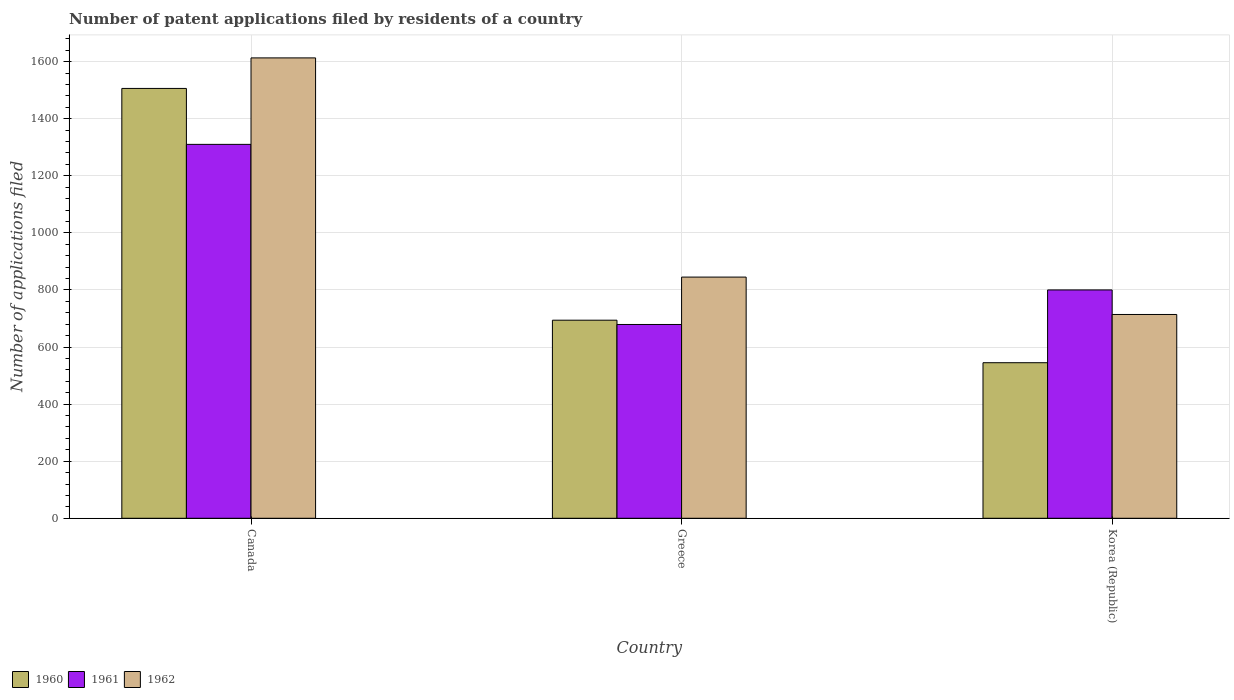How many bars are there on the 2nd tick from the right?
Make the answer very short. 3. In how many cases, is the number of bars for a given country not equal to the number of legend labels?
Ensure brevity in your answer.  0. What is the number of applications filed in 1961 in Greece?
Offer a very short reply. 679. Across all countries, what is the maximum number of applications filed in 1960?
Your answer should be compact. 1506. Across all countries, what is the minimum number of applications filed in 1960?
Your answer should be compact. 545. In which country was the number of applications filed in 1962 minimum?
Your response must be concise. Korea (Republic). What is the total number of applications filed in 1962 in the graph?
Make the answer very short. 3172. What is the difference between the number of applications filed in 1960 in Canada and that in Greece?
Offer a very short reply. 812. What is the difference between the number of applications filed in 1961 in Greece and the number of applications filed in 1962 in Korea (Republic)?
Your answer should be compact. -35. What is the average number of applications filed in 1962 per country?
Provide a succinct answer. 1057.33. What is the difference between the number of applications filed of/in 1962 and number of applications filed of/in 1960 in Greece?
Your answer should be very brief. 151. What is the ratio of the number of applications filed in 1962 in Canada to that in Korea (Republic)?
Provide a succinct answer. 2.26. Is the number of applications filed in 1962 in Greece less than that in Korea (Republic)?
Provide a succinct answer. No. What is the difference between the highest and the second highest number of applications filed in 1961?
Keep it short and to the point. -510. What is the difference between the highest and the lowest number of applications filed in 1962?
Your answer should be very brief. 899. What does the 3rd bar from the left in Korea (Republic) represents?
Provide a short and direct response. 1962. Is it the case that in every country, the sum of the number of applications filed in 1961 and number of applications filed in 1962 is greater than the number of applications filed in 1960?
Your response must be concise. Yes. Are all the bars in the graph horizontal?
Your answer should be very brief. No. What is the difference between two consecutive major ticks on the Y-axis?
Provide a short and direct response. 200. Are the values on the major ticks of Y-axis written in scientific E-notation?
Make the answer very short. No. Does the graph contain any zero values?
Offer a very short reply. No. Does the graph contain grids?
Make the answer very short. Yes. Where does the legend appear in the graph?
Ensure brevity in your answer.  Bottom left. What is the title of the graph?
Keep it short and to the point. Number of patent applications filed by residents of a country. Does "2000" appear as one of the legend labels in the graph?
Offer a terse response. No. What is the label or title of the Y-axis?
Ensure brevity in your answer.  Number of applications filed. What is the Number of applications filed of 1960 in Canada?
Make the answer very short. 1506. What is the Number of applications filed of 1961 in Canada?
Ensure brevity in your answer.  1310. What is the Number of applications filed in 1962 in Canada?
Your answer should be compact. 1613. What is the Number of applications filed of 1960 in Greece?
Your answer should be very brief. 694. What is the Number of applications filed of 1961 in Greece?
Make the answer very short. 679. What is the Number of applications filed in 1962 in Greece?
Keep it short and to the point. 845. What is the Number of applications filed in 1960 in Korea (Republic)?
Give a very brief answer. 545. What is the Number of applications filed of 1961 in Korea (Republic)?
Your answer should be compact. 800. What is the Number of applications filed of 1962 in Korea (Republic)?
Provide a succinct answer. 714. Across all countries, what is the maximum Number of applications filed in 1960?
Offer a very short reply. 1506. Across all countries, what is the maximum Number of applications filed in 1961?
Provide a succinct answer. 1310. Across all countries, what is the maximum Number of applications filed of 1962?
Your answer should be compact. 1613. Across all countries, what is the minimum Number of applications filed in 1960?
Keep it short and to the point. 545. Across all countries, what is the minimum Number of applications filed in 1961?
Your answer should be compact. 679. Across all countries, what is the minimum Number of applications filed in 1962?
Your answer should be very brief. 714. What is the total Number of applications filed in 1960 in the graph?
Your answer should be compact. 2745. What is the total Number of applications filed of 1961 in the graph?
Provide a succinct answer. 2789. What is the total Number of applications filed in 1962 in the graph?
Your answer should be very brief. 3172. What is the difference between the Number of applications filed of 1960 in Canada and that in Greece?
Keep it short and to the point. 812. What is the difference between the Number of applications filed in 1961 in Canada and that in Greece?
Your answer should be compact. 631. What is the difference between the Number of applications filed in 1962 in Canada and that in Greece?
Your answer should be compact. 768. What is the difference between the Number of applications filed in 1960 in Canada and that in Korea (Republic)?
Make the answer very short. 961. What is the difference between the Number of applications filed of 1961 in Canada and that in Korea (Republic)?
Your answer should be very brief. 510. What is the difference between the Number of applications filed of 1962 in Canada and that in Korea (Republic)?
Keep it short and to the point. 899. What is the difference between the Number of applications filed of 1960 in Greece and that in Korea (Republic)?
Give a very brief answer. 149. What is the difference between the Number of applications filed in 1961 in Greece and that in Korea (Republic)?
Provide a succinct answer. -121. What is the difference between the Number of applications filed in 1962 in Greece and that in Korea (Republic)?
Ensure brevity in your answer.  131. What is the difference between the Number of applications filed in 1960 in Canada and the Number of applications filed in 1961 in Greece?
Your response must be concise. 827. What is the difference between the Number of applications filed in 1960 in Canada and the Number of applications filed in 1962 in Greece?
Keep it short and to the point. 661. What is the difference between the Number of applications filed in 1961 in Canada and the Number of applications filed in 1962 in Greece?
Give a very brief answer. 465. What is the difference between the Number of applications filed in 1960 in Canada and the Number of applications filed in 1961 in Korea (Republic)?
Ensure brevity in your answer.  706. What is the difference between the Number of applications filed of 1960 in Canada and the Number of applications filed of 1962 in Korea (Republic)?
Your answer should be very brief. 792. What is the difference between the Number of applications filed in 1961 in Canada and the Number of applications filed in 1962 in Korea (Republic)?
Offer a very short reply. 596. What is the difference between the Number of applications filed in 1960 in Greece and the Number of applications filed in 1961 in Korea (Republic)?
Your response must be concise. -106. What is the difference between the Number of applications filed of 1960 in Greece and the Number of applications filed of 1962 in Korea (Republic)?
Provide a short and direct response. -20. What is the difference between the Number of applications filed of 1961 in Greece and the Number of applications filed of 1962 in Korea (Republic)?
Provide a short and direct response. -35. What is the average Number of applications filed in 1960 per country?
Your answer should be very brief. 915. What is the average Number of applications filed in 1961 per country?
Your answer should be compact. 929.67. What is the average Number of applications filed of 1962 per country?
Give a very brief answer. 1057.33. What is the difference between the Number of applications filed in 1960 and Number of applications filed in 1961 in Canada?
Your answer should be compact. 196. What is the difference between the Number of applications filed in 1960 and Number of applications filed in 1962 in Canada?
Provide a short and direct response. -107. What is the difference between the Number of applications filed in 1961 and Number of applications filed in 1962 in Canada?
Give a very brief answer. -303. What is the difference between the Number of applications filed of 1960 and Number of applications filed of 1962 in Greece?
Provide a succinct answer. -151. What is the difference between the Number of applications filed in 1961 and Number of applications filed in 1962 in Greece?
Your answer should be very brief. -166. What is the difference between the Number of applications filed in 1960 and Number of applications filed in 1961 in Korea (Republic)?
Your response must be concise. -255. What is the difference between the Number of applications filed in 1960 and Number of applications filed in 1962 in Korea (Republic)?
Provide a short and direct response. -169. What is the difference between the Number of applications filed of 1961 and Number of applications filed of 1962 in Korea (Republic)?
Make the answer very short. 86. What is the ratio of the Number of applications filed of 1960 in Canada to that in Greece?
Your response must be concise. 2.17. What is the ratio of the Number of applications filed of 1961 in Canada to that in Greece?
Keep it short and to the point. 1.93. What is the ratio of the Number of applications filed of 1962 in Canada to that in Greece?
Provide a short and direct response. 1.91. What is the ratio of the Number of applications filed in 1960 in Canada to that in Korea (Republic)?
Offer a very short reply. 2.76. What is the ratio of the Number of applications filed of 1961 in Canada to that in Korea (Republic)?
Keep it short and to the point. 1.64. What is the ratio of the Number of applications filed in 1962 in Canada to that in Korea (Republic)?
Provide a short and direct response. 2.26. What is the ratio of the Number of applications filed in 1960 in Greece to that in Korea (Republic)?
Offer a terse response. 1.27. What is the ratio of the Number of applications filed in 1961 in Greece to that in Korea (Republic)?
Offer a very short reply. 0.85. What is the ratio of the Number of applications filed in 1962 in Greece to that in Korea (Republic)?
Your answer should be compact. 1.18. What is the difference between the highest and the second highest Number of applications filed of 1960?
Ensure brevity in your answer.  812. What is the difference between the highest and the second highest Number of applications filed in 1961?
Offer a terse response. 510. What is the difference between the highest and the second highest Number of applications filed of 1962?
Offer a terse response. 768. What is the difference between the highest and the lowest Number of applications filed in 1960?
Provide a short and direct response. 961. What is the difference between the highest and the lowest Number of applications filed of 1961?
Give a very brief answer. 631. What is the difference between the highest and the lowest Number of applications filed of 1962?
Your answer should be compact. 899. 